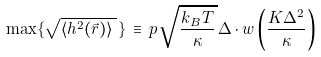<formula> <loc_0><loc_0><loc_500><loc_500>\max \{ \sqrt { \langle h ^ { 2 } ( \vec { r } ) \rangle \, } \, \} \, \equiv \, p \, \sqrt { \frac { k _ { B } T } { \kappa } \, } \Delta \cdot w \left ( \frac { K \Delta ^ { 2 } } { \kappa } \right )</formula> 